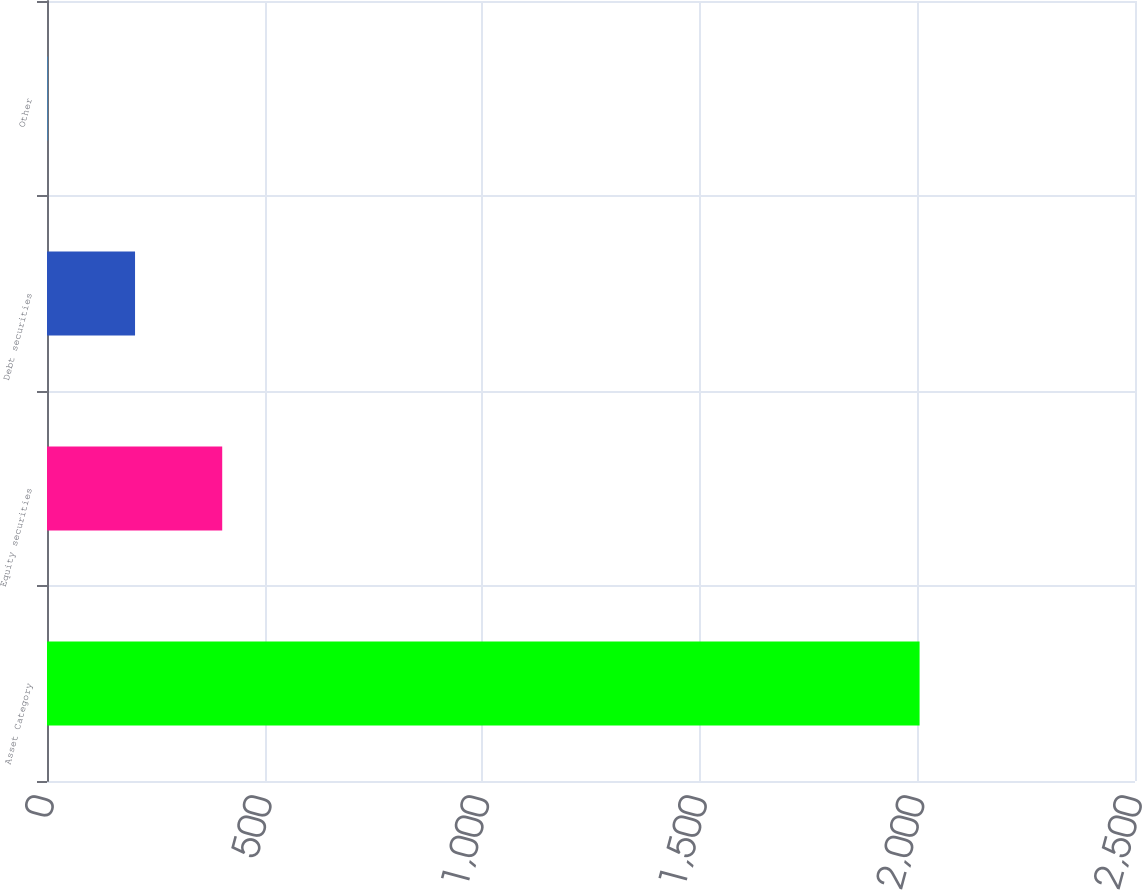Convert chart to OTSL. <chart><loc_0><loc_0><loc_500><loc_500><bar_chart><fcel>Asset Category<fcel>Equity securities<fcel>Debt securities<fcel>Other<nl><fcel>2005<fcel>402.6<fcel>202.3<fcel>2<nl></chart> 